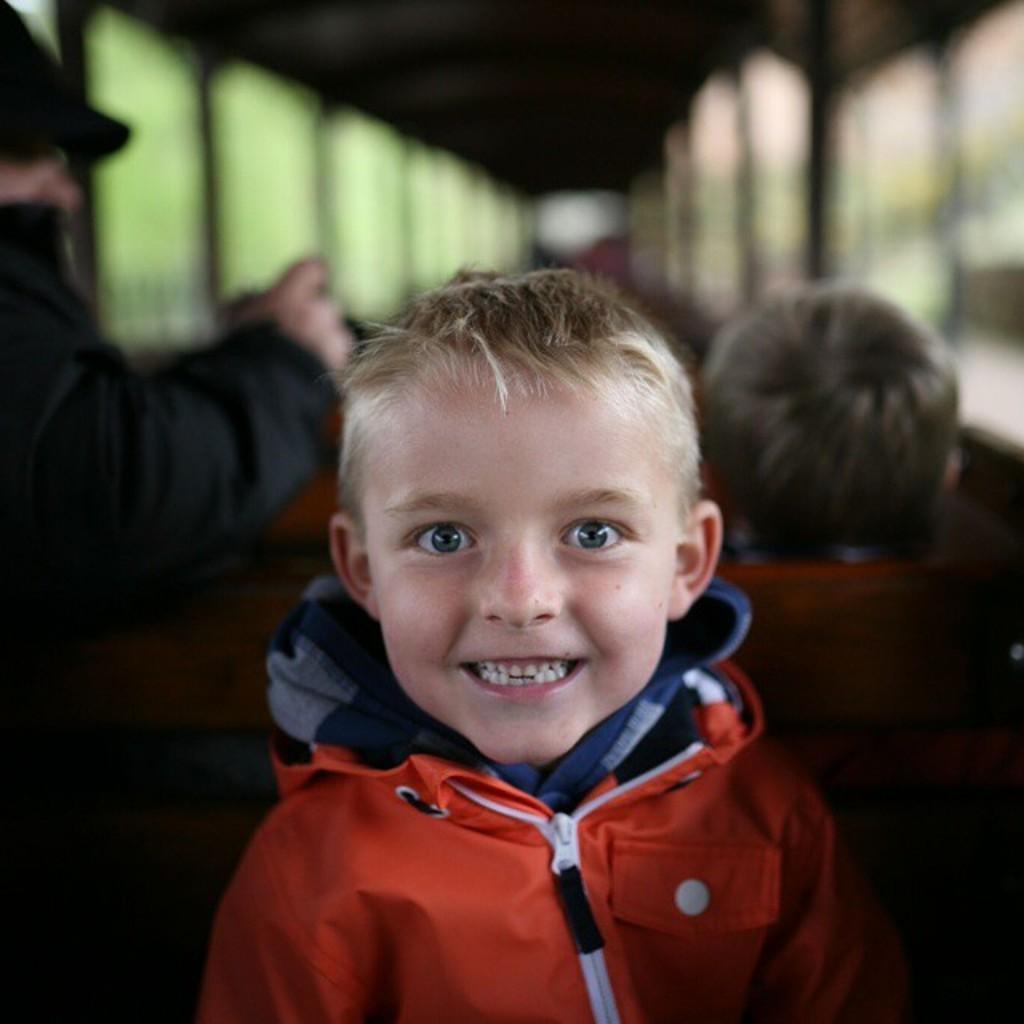Please provide a concise description of this image. In this image, in the middle, we can see a kid. On the left side, we can see a person. On the right side, we can see the head of a kid. In the background, we can see the windows. At the top, we can see black color. 